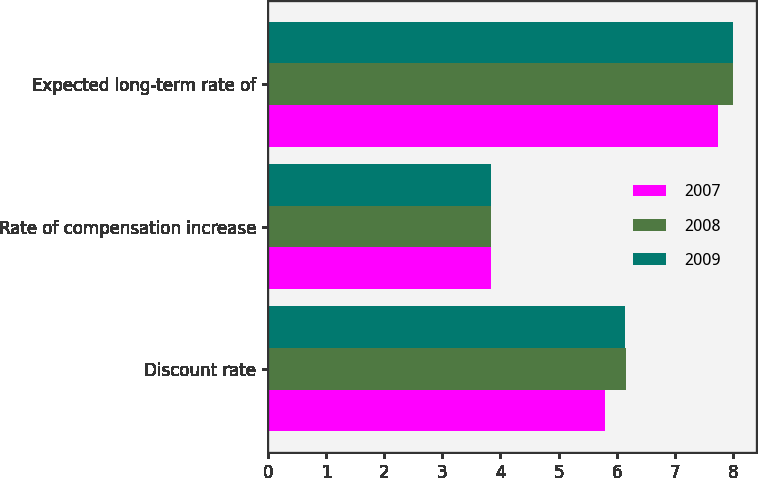<chart> <loc_0><loc_0><loc_500><loc_500><stacked_bar_chart><ecel><fcel>Discount rate<fcel>Rate of compensation increase<fcel>Expected long-term rate of<nl><fcel>2007<fcel>5.79<fcel>3.84<fcel>7.75<nl><fcel>2008<fcel>6.16<fcel>3.84<fcel>8<nl><fcel>2009<fcel>6.14<fcel>3.84<fcel>8<nl></chart> 